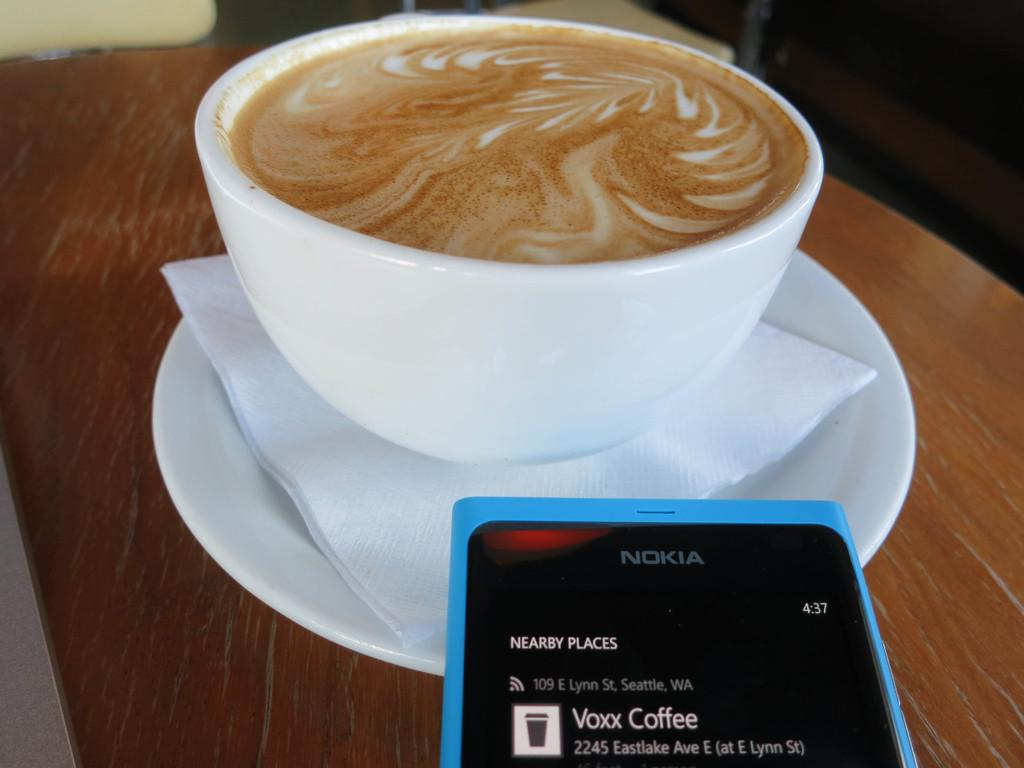What piece of furniture is present in the image? There is a table in the image. What is placed on the table? There is a saucer, tissue paper, a mobile, and a cup with coffee on the table. What type of beverage is in the cup on the table? There is coffee in the cup on the table. What appliance is being used to stimulate the nerves of the mice in the image? There are no appliances, nerves, or mice present in the image. 